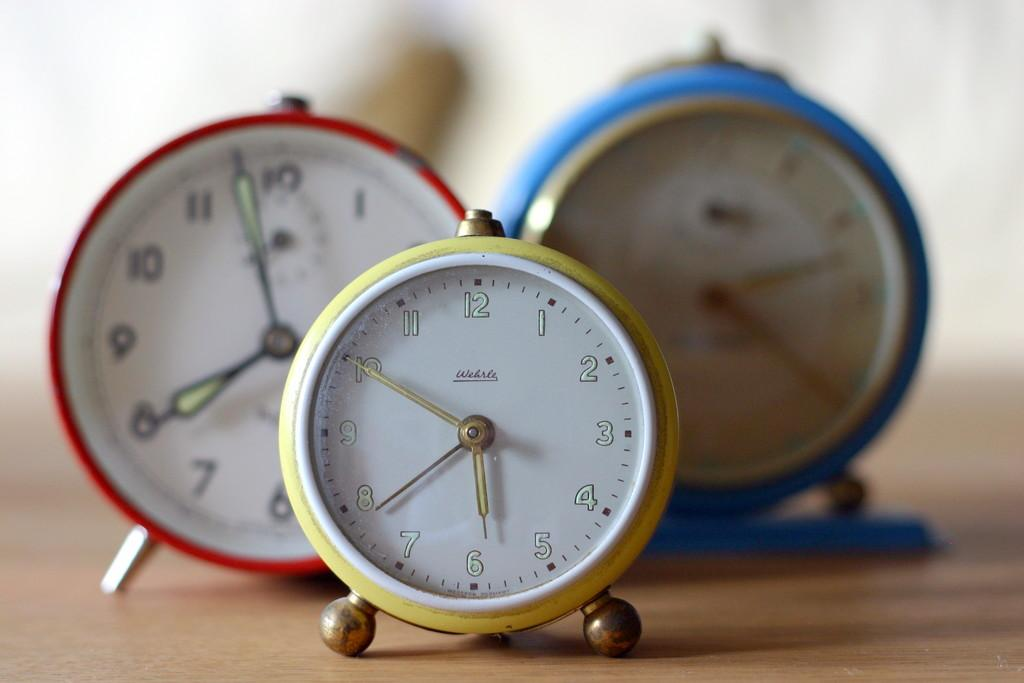<image>
Provide a brief description of the given image. Three round alarm clocks showing 7:57, 5:50, and 2:20. 